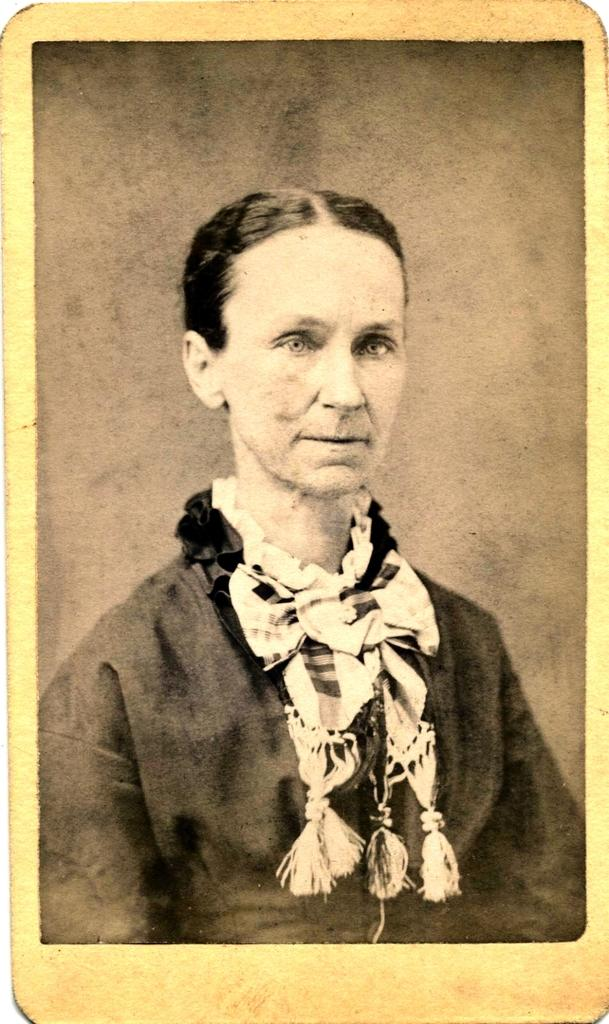What is the main subject of the image? The main subject of the image is a photograph of a woman. What is the woman in the photograph wearing? The woman in the photograph wore a scarf. What is the color scheme of the photograph? The photograph is black and white. Did the earthquake cause any damage to the roof in the image? There is no mention of an earthquake or a roof in the image, as it only features a black and white photograph of a woman wearing a scarf. 